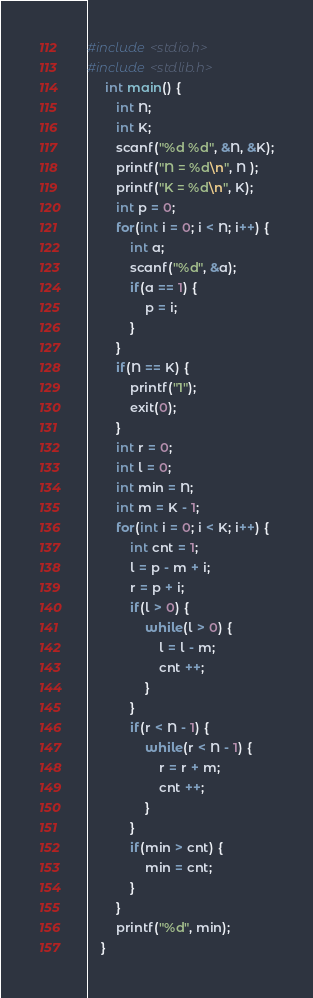<code> <loc_0><loc_0><loc_500><loc_500><_C_>#include <stdio.h>
#include <stdlib.h>
     int main() {
        int N;
        int K;
        scanf("%d %d", &N, &K);
        printf("N = %d\n", N );
        printf("K = %d\n", K);
        int p = 0;
        for(int i = 0; i < N; i++) {
            int a;
            scanf("%d", &a);
            if(a == 1) {
                p = i;
            }
        }
        if(N == K) {
            printf("1");
            exit(0);
        }
        int r = 0;
        int l = 0;
        int min = N;
        int m = K - 1;
        for(int i = 0; i < K; i++) {
            int cnt = 1;
            l = p - m + i;
            r = p + i;
            if(l > 0) {
                while(l > 0) {
                    l = l - m;
                    cnt ++;
                }
            }
            if(r < N - 1) {
                while(r < N - 1) {
                    r = r + m;
                    cnt ++;
                }
            }
            if(min > cnt) {
                min = cnt;
            }
        }
        printf("%d", min);
    }
</code> 